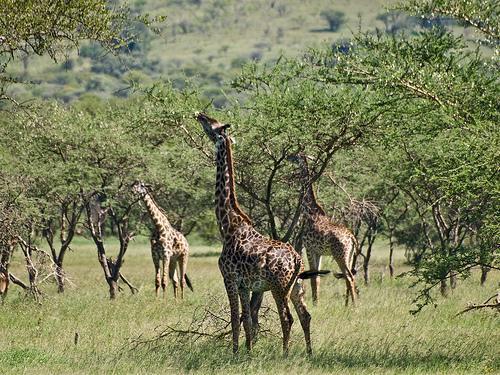How many giraffes are there?
Give a very brief answer. 3. 